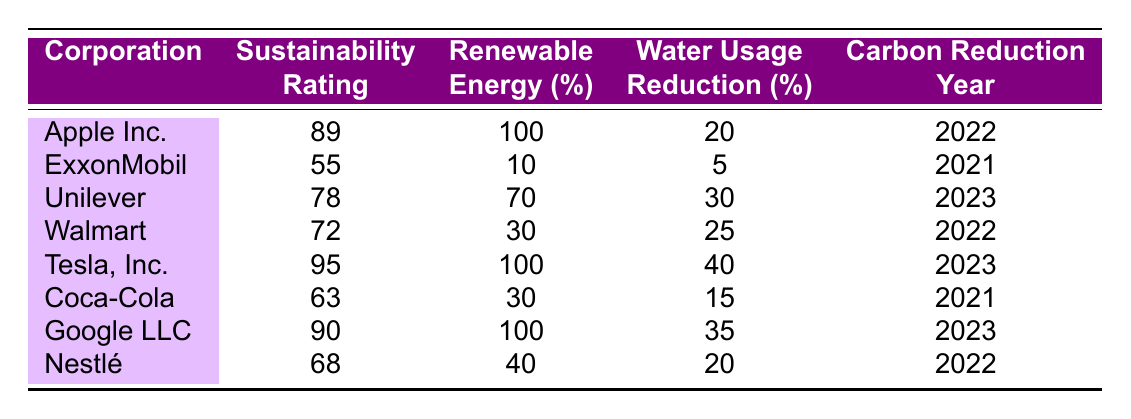What is the sustainability rating of Tesla, Inc.? The table directly lists the sustainability rating for Tesla, Inc. as 95.
Answer: 95 Which corporation has the highest renewable energy percentage? By comparing the renewable energy percentages listed, Tesla, Inc. and Apple Inc. both have 100%, which is the highest percentage.
Answer: Tesla, Inc. and Apple Inc What is the average water usage reduction percentage across all corporations? The water usage reductions are 20, 5, 30, 25, 40, 15, 35, and 20. Adding these values gives 20 + 5 + 30 + 25 + 40 + 15 + 35 + 20 = 190. Dividing by 8 corporations gives an average of 190/8 = 23.75.
Answer: 23.75 Is Unilever's sustainability rating above 75? The table shows that Unilever's sustainability rating is 78, which is above 75.
Answer: Yes Which corporation reduced carbon emissions in 2023, and how does its sustainability rating compare to others? Tesla, Inc. and Unilever both reduced carbon emissions in 2023. Tesla has a sustainability rating of 95, which is the highest; Unilever has a rating of 78, which is lower.
Answer: Tesla, Inc. and Unilever; Tesla is highest What percentage of renewable energy does ExxonMobil use, and is it less than 20%? ExxonMobil's renewable energy percentage is listed as 10%. Since 10% is less than 20%, the answer is yes.
Answer: Yes How many corporations have a sustainability rating over 80? Looking at the table, the corporations with ratings over 80 are Apple Inc. (89), Tesla, Inc. (95), and Google LLC (90). That makes a total of 3 corporations.
Answer: 3 What is the difference between the sustainability ratings of Coca-Cola and Nestlé? The sustainability rating for Coca-Cola is 63, and for Nestlé, it is 68. The difference is 68 - 63 = 5.
Answer: 5 Which corporation has the worst water usage reduction percentage, and what is that percentage? By examining the water usage reductions, ExxonMobil has the lowest at 5%.
Answer: ExxonMobil; 5% Is the average sustainability rating of corporations above 70? The ratings are 89, 55, 78, 72, 95, 63, 90, and 68. The average is (89 + 55 + 78 + 72 + 95 + 63 + 90 + 68) / 8 = 78.75, which is above 70.
Answer: Yes 